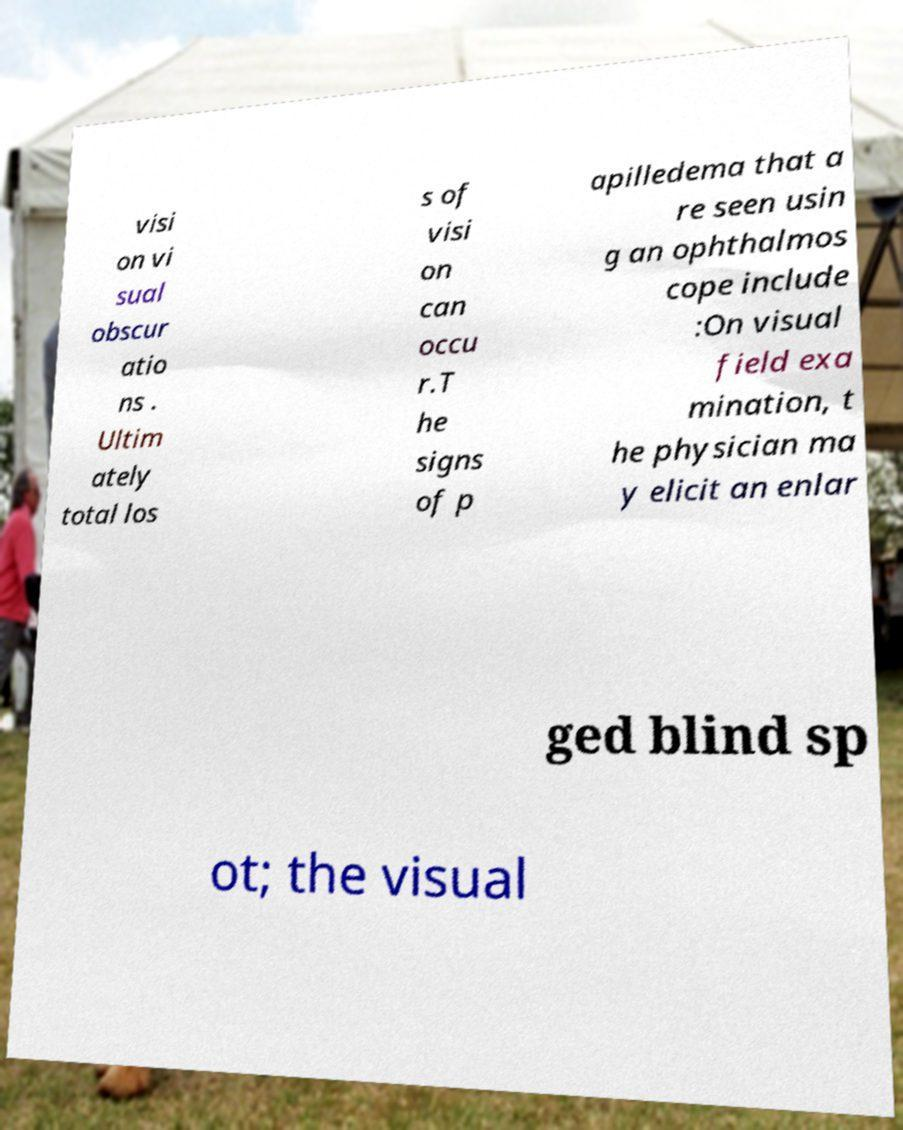For documentation purposes, I need the text within this image transcribed. Could you provide that? visi on vi sual obscur atio ns . Ultim ately total los s of visi on can occu r.T he signs of p apilledema that a re seen usin g an ophthalmos cope include :On visual field exa mination, t he physician ma y elicit an enlar ged blind sp ot; the visual 